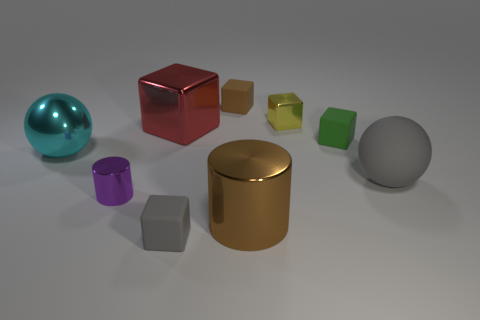Subtract all small yellow cubes. How many cubes are left? 4 Subtract all red cubes. How many cubes are left? 4 Add 1 yellow cubes. How many objects exist? 10 Subtract 1 blocks. How many blocks are left? 4 Subtract all purple blocks. Subtract all yellow balls. How many blocks are left? 5 Subtract all purple balls. How many yellow cubes are left? 1 Subtract all gray spheres. Subtract all purple blocks. How many objects are left? 8 Add 3 cyan metallic balls. How many cyan metallic balls are left? 4 Add 6 tiny matte cubes. How many tiny matte cubes exist? 9 Subtract 1 cyan spheres. How many objects are left? 8 